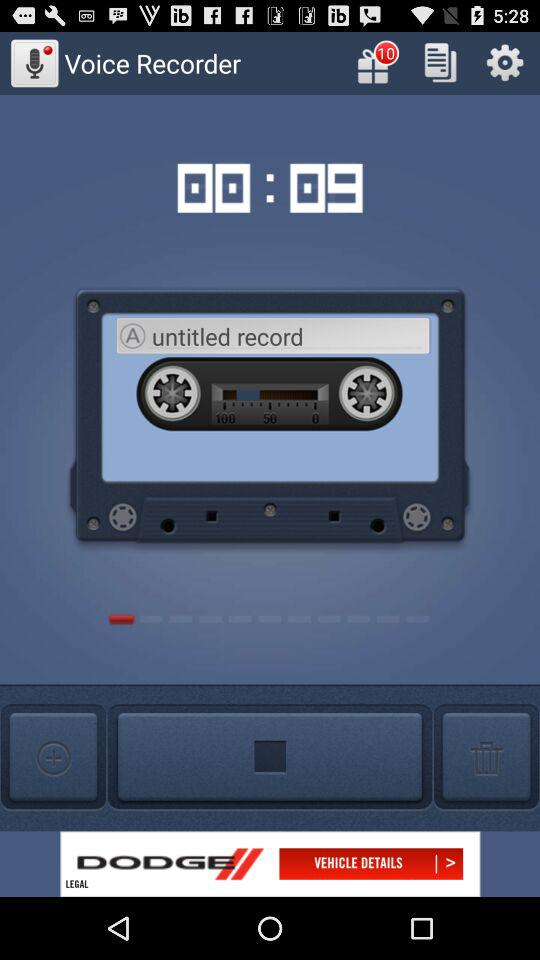What is the duration shown in the application? The shown duration is 9 seconds. 